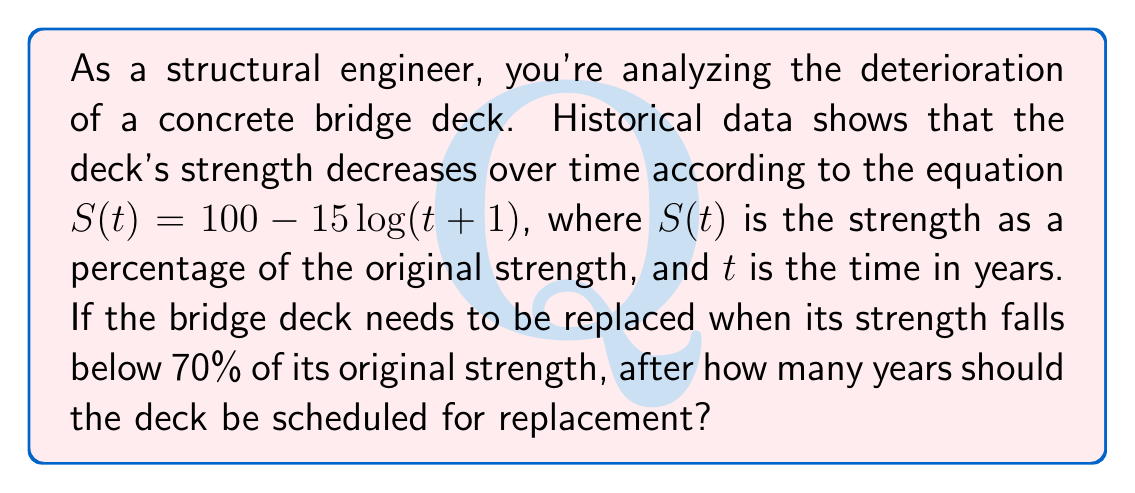Give your solution to this math problem. Let's approach this step-by-step:

1) We need to find the time $t$ when the strength $S(t)$ equals 70%.

2) We can set up the equation:
   $70 = 100 - 15 \log(t+1)$

3) Subtract 100 from both sides:
   $-30 = -15 \log(t+1)$

4) Divide both sides by -15:
   $2 = \log(t+1)$

5) Now we need to solve for $t$. We can use the exponential function (base 10) on both sides:
   $10^2 = t+1$

6) Simplify:
   $100 = t+1$

7) Subtract 1 from both sides:
   $99 = t$

Therefore, the bridge deck should be scheduled for replacement after 99 years.
Answer: 99 years 